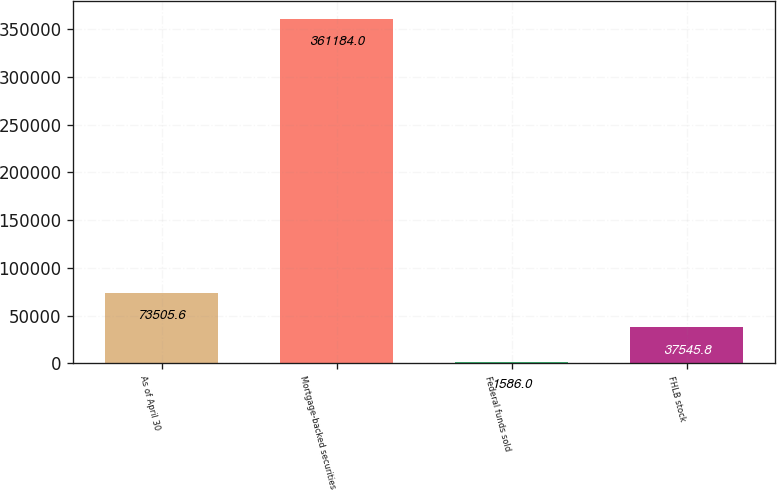<chart> <loc_0><loc_0><loc_500><loc_500><bar_chart><fcel>As of April 30<fcel>Mortgage-backed securities<fcel>Federal funds sold<fcel>FHLB stock<nl><fcel>73505.6<fcel>361184<fcel>1586<fcel>37545.8<nl></chart> 